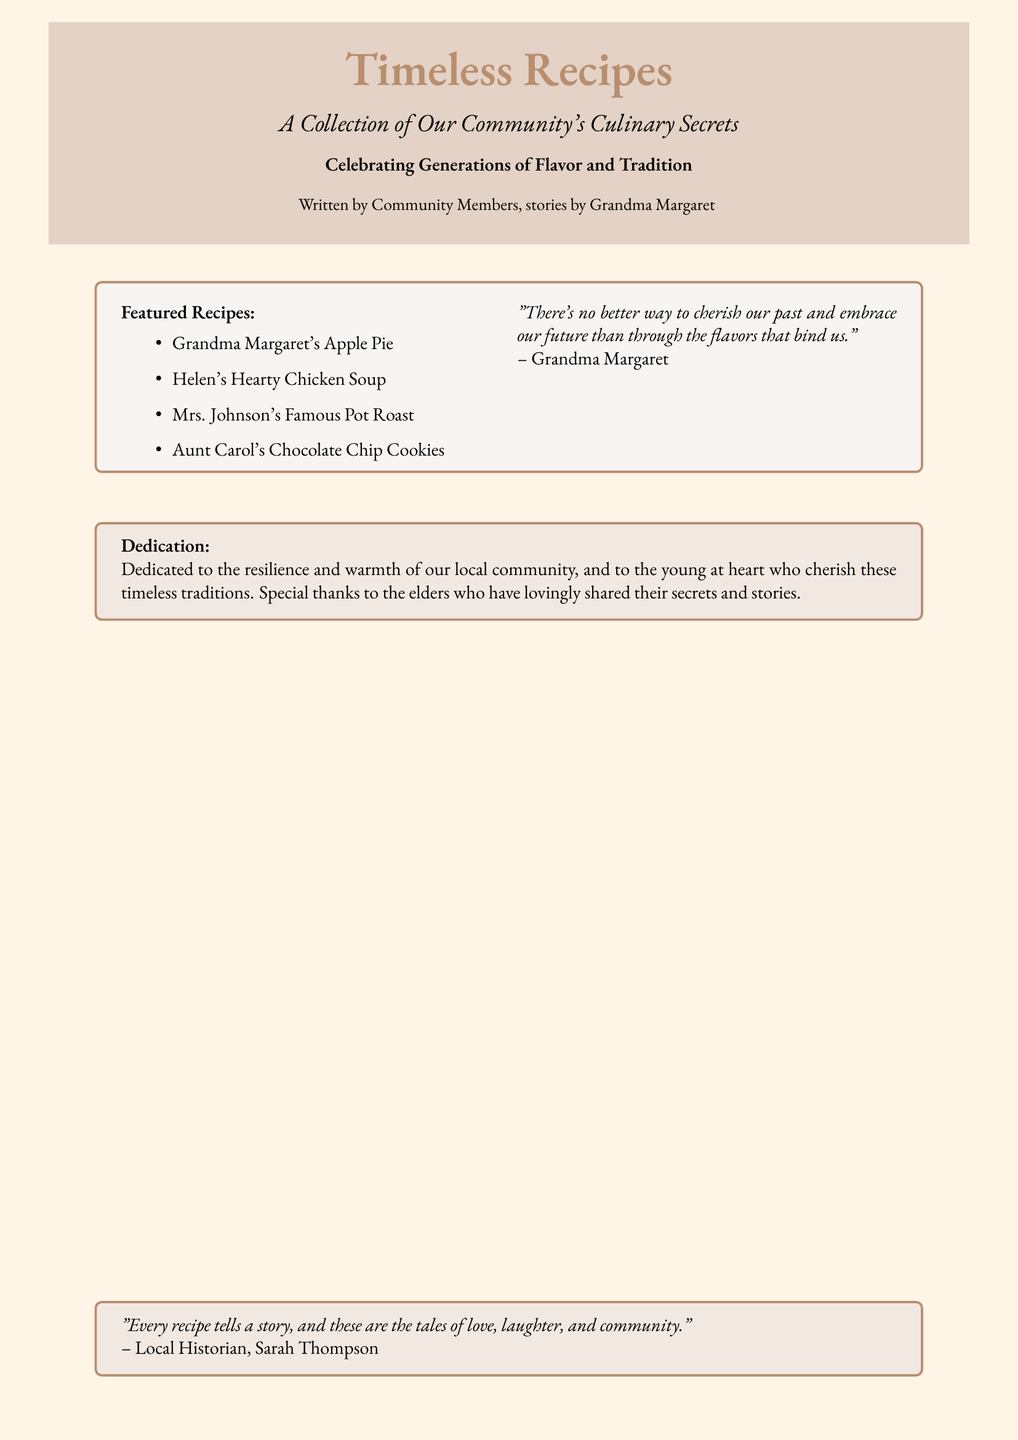What is the book title? The title is prominently displayed in a large font on the book cover.
Answer: Timeless Recipes Who wrote the book? The authorship information is included at the bottom of the cover.
Answer: Community Members What is the main theme of the book? The theme is indicated in the subtitle and other descriptive text.
Answer: Culinary Secrets Which recipe is featured first? The featured recipes are listed in bullet points, with the first recipe at the top.
Answer: Grandma Margaret's Apple Pie Who is the dedication for? The dedication section gives thanks to specific groups mentioned in the text.
Answer: The local community What type of food does Aunt Carol's recipe represent? The recipe list categorizes the types of dishes.
Answer: Cookies What phrase is quoted from Grandma Margaret? The quote from Grandma Margaret reflects on the book's significance.
Answer: "There's no better way to cherish our past and embrace our future than through the flavors that bind us." What style does the book cover incorporate? The aesthetic details can be seen in the colors and fonts used throughout the cover.
Answer: Rustic How is the book dedicated? The dedication section outlines who the book honors.
Answer: To the resilience and warmth of our local community 